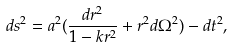<formula> <loc_0><loc_0><loc_500><loc_500>d s ^ { 2 } = a ^ { 2 } ( \frac { d r ^ { 2 } } { 1 - k r ^ { 2 } } + r ^ { 2 } d \Omega ^ { 2 } ) - d t ^ { 2 } ,</formula> 